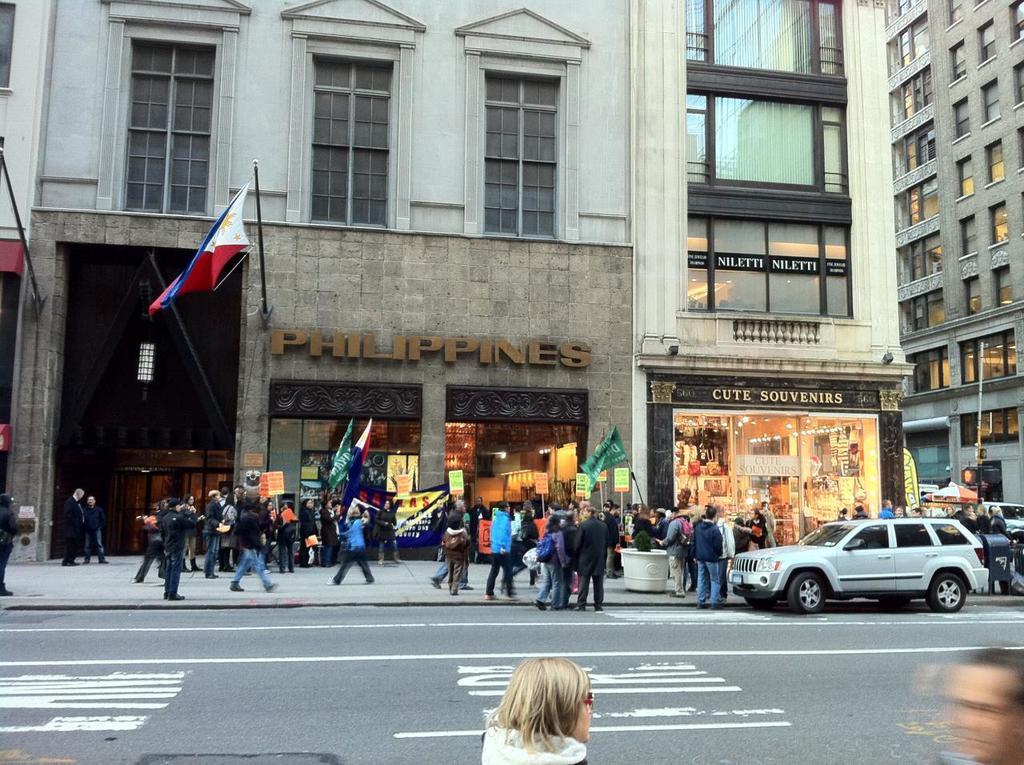Can you describe this image briefly? In this image in front there are two people standing on the road. There is a car parked on the road. In the background of the image there are buildings, flags. In front of the buildings there are people walking on the pavement. 